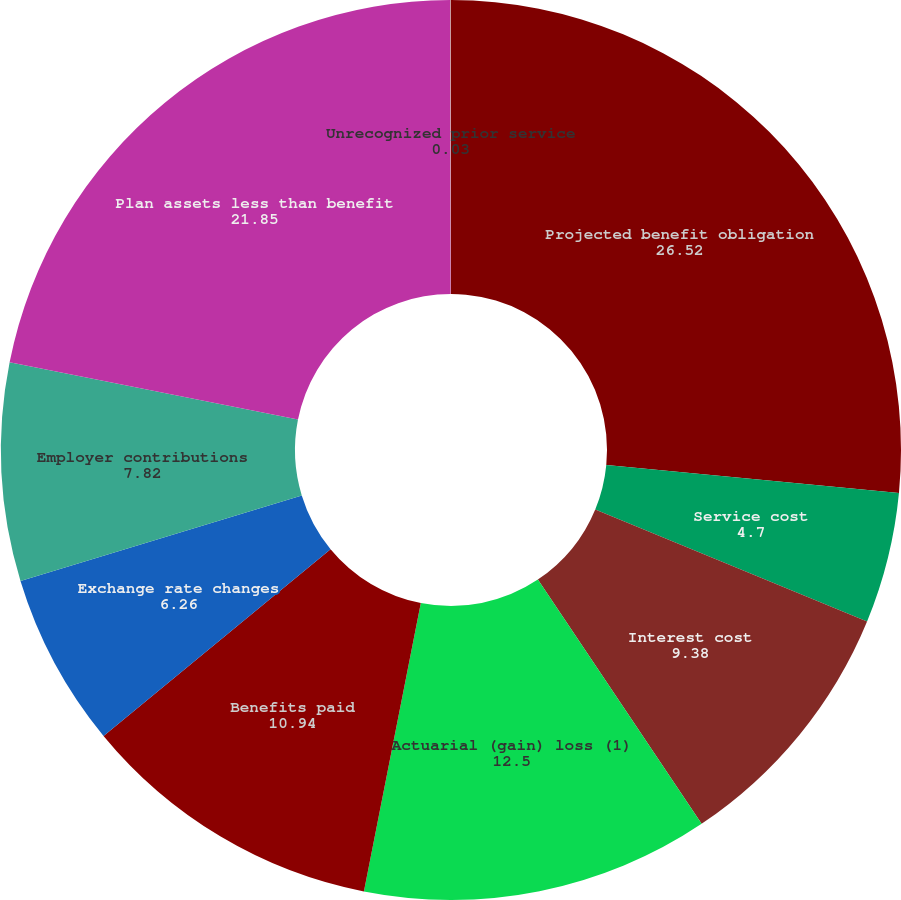Convert chart to OTSL. <chart><loc_0><loc_0><loc_500><loc_500><pie_chart><fcel>Projected benefit obligation<fcel>Service cost<fcel>Interest cost<fcel>Actuarial (gain) loss (1)<fcel>Benefits paid<fcel>Exchange rate changes<fcel>Employer contributions<fcel>Plan assets less than benefit<fcel>Unrecognized prior service<nl><fcel>26.52%<fcel>4.7%<fcel>9.38%<fcel>12.5%<fcel>10.94%<fcel>6.26%<fcel>7.82%<fcel>21.85%<fcel>0.03%<nl></chart> 